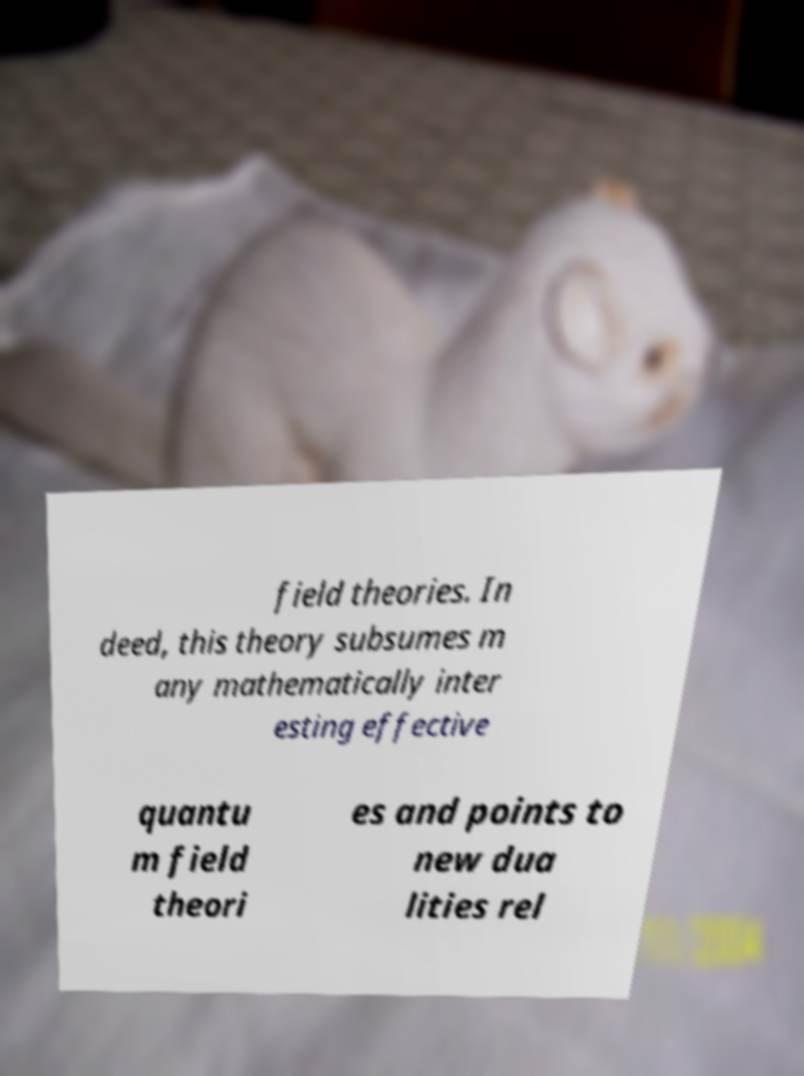Could you extract and type out the text from this image? field theories. In deed, this theory subsumes m any mathematically inter esting effective quantu m field theori es and points to new dua lities rel 